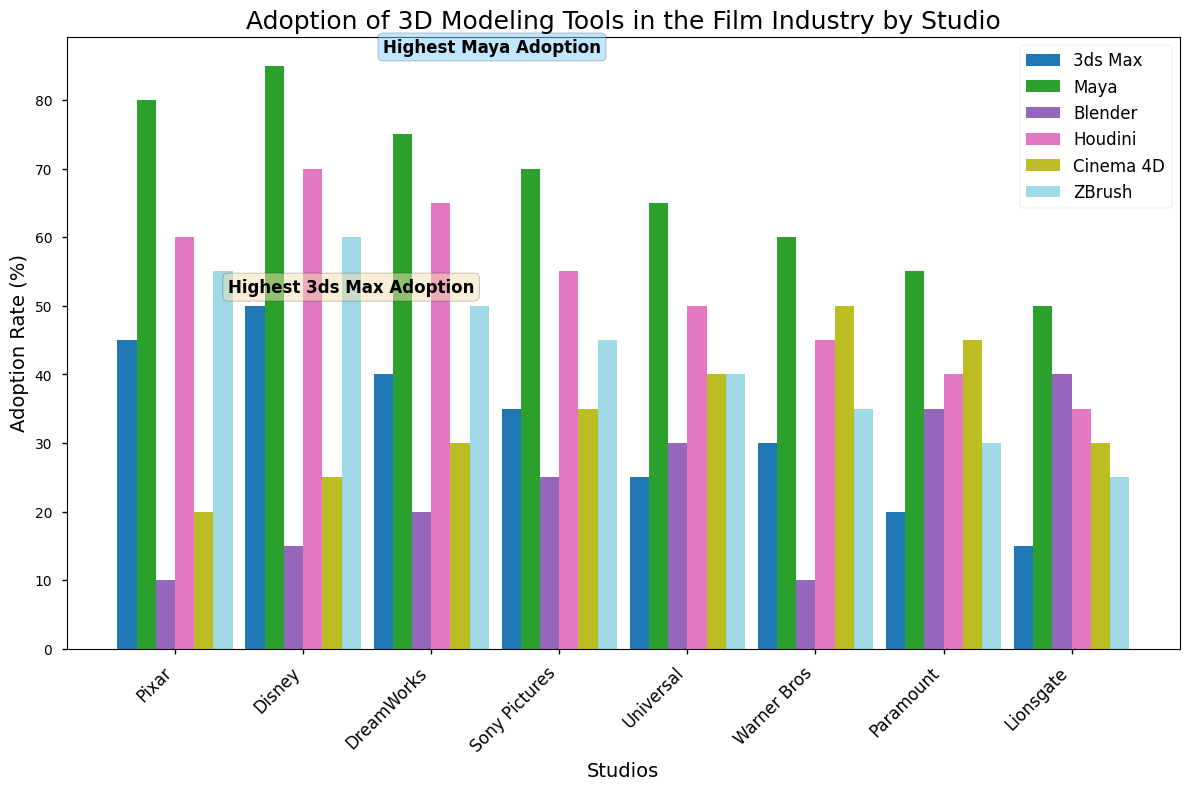What are the two studios with the highest adoption rates of 3ds Max and Maya respectively? The highest 3ds Max adoption rate is by Disney with a rate of 50%. The highest Maya adoption rate is by Disney with a rate of 85%. Both these values can be identified by looking at the labels on the bars and the annotation text indicating the highest adoption rates for 3ds Max and Maya.
Answer: Disney, Disney Which studio has the lowest adoption rate for ZBrush? To determine the lowest adoption rate for ZBrush, we examine the heights of the ZBrush bars for all studios and find that Lionsgate has the lowest adoption rate with a value of 25%.
Answer: Lionsgate How does the adoption rate of Blender at Universal compare to Sony Pictures? By comparing the heights of the Blender bars of Universal and Sony Pictures, we see that Universal has an adoption rate of 30%, while Sony Pictures has a slightly higher rate of 25%. Therefore, Sony Pictures has a higher adoption rate for Blender.
Answer: Sony Pictures What is the average adoption rate of Cinema 4D across all studios? To find the average adoption rate of Cinema 4D, sum the adoption rates across all the studios: 20 + 25 + 30 + 35 + 40 + 45 + 50 + 30, which equals 275. Dividing this by the number of studios, 8, we get an average of 275 / 8 = 34.375%.
Answer: 34.375% Which software has the highest overall adoption rate across all studios, and what is it? To identify the software with the highest overall adoption rate, sum the adoption rates for each software across all studios and find the highest total. Maya has the highest total adoption rate: 80 + 85 + 75 + 70 + 65 + 60 + 55 + 50 = 540%.
Answer: Maya How much higher is the adoption rate of Houdini at DreamWorks compared to Warner Bros? The adoption rate for Houdini at DreamWorks is 65%, and at Warner Bros, it is 45%. Subtracting these values, we get 65% - 45% = 20%. Hence, the adoption rate at DreamWorks is 20% higher than at Warner Bros.
Answer: 20% What is the total adoption rate for 3ds Max at Pixar and Lionsgate? The adoption rates for 3ds Max at Pixar and Lionsgate are 45% and 15% respectively. Adding these values, we get 45% + 15% = 60%.
Answer: 60% Which studio shows the highest diversity in the adoption rates across all software tools, and how is it illustrated? Universal shows the highest diversity in adoption rates with significant differences across the values: 3ds Max (25), Maya (65), Blender (30), Houdini (50), Cinema 4D (40), and ZBrush (40). These values can be seen as distinctly different heights of bars, indicating a wide range of adoption levels.
Answer: Universal 